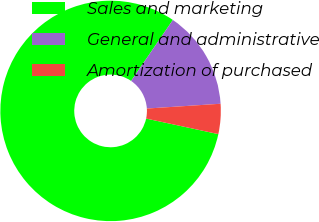<chart> <loc_0><loc_0><loc_500><loc_500><pie_chart><fcel>Sales and marketing<fcel>General and administrative<fcel>Amortization of purchased<nl><fcel>81.18%<fcel>14.41%<fcel>4.41%<nl></chart> 